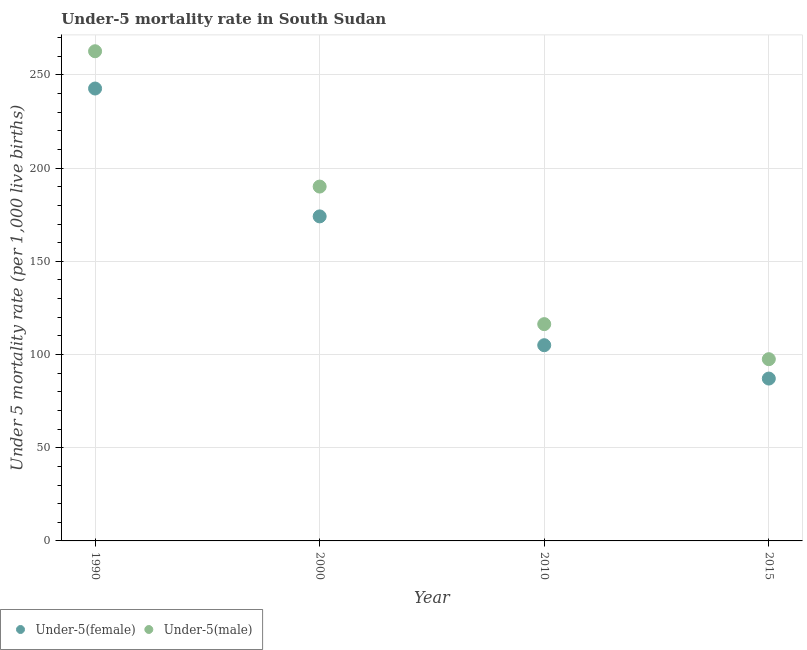What is the under-5 female mortality rate in 2015?
Your answer should be very brief. 87.1. Across all years, what is the maximum under-5 female mortality rate?
Your answer should be very brief. 242.7. Across all years, what is the minimum under-5 male mortality rate?
Make the answer very short. 97.5. In which year was the under-5 female mortality rate maximum?
Give a very brief answer. 1990. In which year was the under-5 female mortality rate minimum?
Ensure brevity in your answer.  2015. What is the total under-5 male mortality rate in the graph?
Your answer should be compact. 666.6. What is the difference between the under-5 male mortality rate in 2000 and that in 2015?
Ensure brevity in your answer.  92.6. What is the difference between the under-5 male mortality rate in 2000 and the under-5 female mortality rate in 2015?
Offer a very short reply. 103. What is the average under-5 male mortality rate per year?
Keep it short and to the point. 166.65. In the year 2015, what is the difference between the under-5 male mortality rate and under-5 female mortality rate?
Offer a very short reply. 10.4. What is the ratio of the under-5 female mortality rate in 2010 to that in 2015?
Give a very brief answer. 1.21. What is the difference between the highest and the second highest under-5 female mortality rate?
Provide a succinct answer. 68.6. What is the difference between the highest and the lowest under-5 female mortality rate?
Provide a short and direct response. 155.6. In how many years, is the under-5 male mortality rate greater than the average under-5 male mortality rate taken over all years?
Provide a short and direct response. 2. Is the under-5 male mortality rate strictly greater than the under-5 female mortality rate over the years?
Make the answer very short. Yes. Is the under-5 female mortality rate strictly less than the under-5 male mortality rate over the years?
Offer a very short reply. Yes. How many dotlines are there?
Offer a very short reply. 2. How many years are there in the graph?
Make the answer very short. 4. What is the difference between two consecutive major ticks on the Y-axis?
Provide a short and direct response. 50. Does the graph contain grids?
Keep it short and to the point. Yes. What is the title of the graph?
Ensure brevity in your answer.  Under-5 mortality rate in South Sudan. Does "Investment" appear as one of the legend labels in the graph?
Your answer should be compact. No. What is the label or title of the X-axis?
Give a very brief answer. Year. What is the label or title of the Y-axis?
Offer a terse response. Under 5 mortality rate (per 1,0 live births). What is the Under 5 mortality rate (per 1,000 live births) in Under-5(female) in 1990?
Provide a short and direct response. 242.7. What is the Under 5 mortality rate (per 1,000 live births) in Under-5(male) in 1990?
Your answer should be compact. 262.7. What is the Under 5 mortality rate (per 1,000 live births) in Under-5(female) in 2000?
Ensure brevity in your answer.  174.1. What is the Under 5 mortality rate (per 1,000 live births) of Under-5(male) in 2000?
Ensure brevity in your answer.  190.1. What is the Under 5 mortality rate (per 1,000 live births) in Under-5(female) in 2010?
Offer a very short reply. 105. What is the Under 5 mortality rate (per 1,000 live births) of Under-5(male) in 2010?
Keep it short and to the point. 116.3. What is the Under 5 mortality rate (per 1,000 live births) of Under-5(female) in 2015?
Give a very brief answer. 87.1. What is the Under 5 mortality rate (per 1,000 live births) in Under-5(male) in 2015?
Your answer should be very brief. 97.5. Across all years, what is the maximum Under 5 mortality rate (per 1,000 live births) of Under-5(female)?
Provide a short and direct response. 242.7. Across all years, what is the maximum Under 5 mortality rate (per 1,000 live births) of Under-5(male)?
Your response must be concise. 262.7. Across all years, what is the minimum Under 5 mortality rate (per 1,000 live births) in Under-5(female)?
Offer a terse response. 87.1. Across all years, what is the minimum Under 5 mortality rate (per 1,000 live births) in Under-5(male)?
Offer a very short reply. 97.5. What is the total Under 5 mortality rate (per 1,000 live births) in Under-5(female) in the graph?
Your response must be concise. 608.9. What is the total Under 5 mortality rate (per 1,000 live births) in Under-5(male) in the graph?
Offer a very short reply. 666.6. What is the difference between the Under 5 mortality rate (per 1,000 live births) in Under-5(female) in 1990 and that in 2000?
Provide a short and direct response. 68.6. What is the difference between the Under 5 mortality rate (per 1,000 live births) in Under-5(male) in 1990 and that in 2000?
Provide a short and direct response. 72.6. What is the difference between the Under 5 mortality rate (per 1,000 live births) in Under-5(female) in 1990 and that in 2010?
Provide a succinct answer. 137.7. What is the difference between the Under 5 mortality rate (per 1,000 live births) of Under-5(male) in 1990 and that in 2010?
Give a very brief answer. 146.4. What is the difference between the Under 5 mortality rate (per 1,000 live births) of Under-5(female) in 1990 and that in 2015?
Make the answer very short. 155.6. What is the difference between the Under 5 mortality rate (per 1,000 live births) of Under-5(male) in 1990 and that in 2015?
Provide a short and direct response. 165.2. What is the difference between the Under 5 mortality rate (per 1,000 live births) in Under-5(female) in 2000 and that in 2010?
Offer a terse response. 69.1. What is the difference between the Under 5 mortality rate (per 1,000 live births) in Under-5(male) in 2000 and that in 2010?
Keep it short and to the point. 73.8. What is the difference between the Under 5 mortality rate (per 1,000 live births) of Under-5(male) in 2000 and that in 2015?
Keep it short and to the point. 92.6. What is the difference between the Under 5 mortality rate (per 1,000 live births) in Under-5(female) in 2010 and that in 2015?
Give a very brief answer. 17.9. What is the difference between the Under 5 mortality rate (per 1,000 live births) of Under-5(male) in 2010 and that in 2015?
Your answer should be very brief. 18.8. What is the difference between the Under 5 mortality rate (per 1,000 live births) of Under-5(female) in 1990 and the Under 5 mortality rate (per 1,000 live births) of Under-5(male) in 2000?
Provide a succinct answer. 52.6. What is the difference between the Under 5 mortality rate (per 1,000 live births) of Under-5(female) in 1990 and the Under 5 mortality rate (per 1,000 live births) of Under-5(male) in 2010?
Your answer should be very brief. 126.4. What is the difference between the Under 5 mortality rate (per 1,000 live births) in Under-5(female) in 1990 and the Under 5 mortality rate (per 1,000 live births) in Under-5(male) in 2015?
Give a very brief answer. 145.2. What is the difference between the Under 5 mortality rate (per 1,000 live births) of Under-5(female) in 2000 and the Under 5 mortality rate (per 1,000 live births) of Under-5(male) in 2010?
Give a very brief answer. 57.8. What is the difference between the Under 5 mortality rate (per 1,000 live births) in Under-5(female) in 2000 and the Under 5 mortality rate (per 1,000 live births) in Under-5(male) in 2015?
Your response must be concise. 76.6. What is the average Under 5 mortality rate (per 1,000 live births) of Under-5(female) per year?
Provide a short and direct response. 152.22. What is the average Under 5 mortality rate (per 1,000 live births) in Under-5(male) per year?
Provide a succinct answer. 166.65. In the year 1990, what is the difference between the Under 5 mortality rate (per 1,000 live births) in Under-5(female) and Under 5 mortality rate (per 1,000 live births) in Under-5(male)?
Your response must be concise. -20. In the year 2000, what is the difference between the Under 5 mortality rate (per 1,000 live births) of Under-5(female) and Under 5 mortality rate (per 1,000 live births) of Under-5(male)?
Keep it short and to the point. -16. In the year 2010, what is the difference between the Under 5 mortality rate (per 1,000 live births) in Under-5(female) and Under 5 mortality rate (per 1,000 live births) in Under-5(male)?
Your answer should be very brief. -11.3. In the year 2015, what is the difference between the Under 5 mortality rate (per 1,000 live births) in Under-5(female) and Under 5 mortality rate (per 1,000 live births) in Under-5(male)?
Your answer should be very brief. -10.4. What is the ratio of the Under 5 mortality rate (per 1,000 live births) in Under-5(female) in 1990 to that in 2000?
Offer a terse response. 1.39. What is the ratio of the Under 5 mortality rate (per 1,000 live births) of Under-5(male) in 1990 to that in 2000?
Your answer should be compact. 1.38. What is the ratio of the Under 5 mortality rate (per 1,000 live births) of Under-5(female) in 1990 to that in 2010?
Your response must be concise. 2.31. What is the ratio of the Under 5 mortality rate (per 1,000 live births) of Under-5(male) in 1990 to that in 2010?
Keep it short and to the point. 2.26. What is the ratio of the Under 5 mortality rate (per 1,000 live births) of Under-5(female) in 1990 to that in 2015?
Offer a very short reply. 2.79. What is the ratio of the Under 5 mortality rate (per 1,000 live births) in Under-5(male) in 1990 to that in 2015?
Keep it short and to the point. 2.69. What is the ratio of the Under 5 mortality rate (per 1,000 live births) in Under-5(female) in 2000 to that in 2010?
Give a very brief answer. 1.66. What is the ratio of the Under 5 mortality rate (per 1,000 live births) in Under-5(male) in 2000 to that in 2010?
Offer a terse response. 1.63. What is the ratio of the Under 5 mortality rate (per 1,000 live births) in Under-5(female) in 2000 to that in 2015?
Ensure brevity in your answer.  2. What is the ratio of the Under 5 mortality rate (per 1,000 live births) in Under-5(male) in 2000 to that in 2015?
Give a very brief answer. 1.95. What is the ratio of the Under 5 mortality rate (per 1,000 live births) of Under-5(female) in 2010 to that in 2015?
Offer a very short reply. 1.21. What is the ratio of the Under 5 mortality rate (per 1,000 live births) of Under-5(male) in 2010 to that in 2015?
Provide a short and direct response. 1.19. What is the difference between the highest and the second highest Under 5 mortality rate (per 1,000 live births) of Under-5(female)?
Your response must be concise. 68.6. What is the difference between the highest and the second highest Under 5 mortality rate (per 1,000 live births) of Under-5(male)?
Make the answer very short. 72.6. What is the difference between the highest and the lowest Under 5 mortality rate (per 1,000 live births) in Under-5(female)?
Ensure brevity in your answer.  155.6. What is the difference between the highest and the lowest Under 5 mortality rate (per 1,000 live births) in Under-5(male)?
Provide a short and direct response. 165.2. 